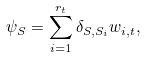<formula> <loc_0><loc_0><loc_500><loc_500>\psi _ { S } = \sum _ { i = 1 } ^ { r _ { t } } \delta _ { S , S _ { i } } w _ { i , t } ,</formula> 